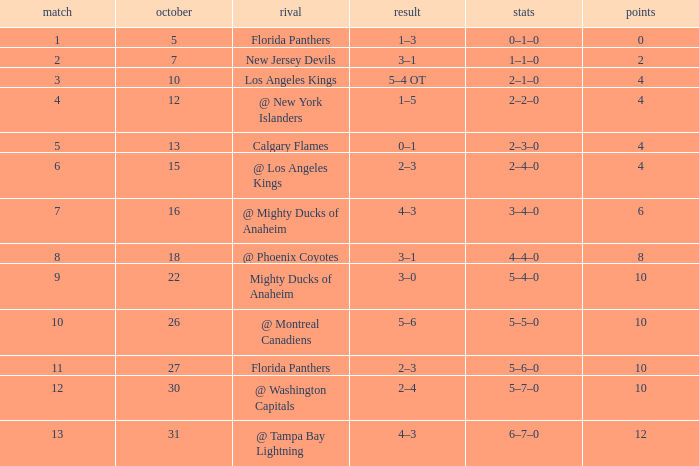What team has a score of 2 3–1. 